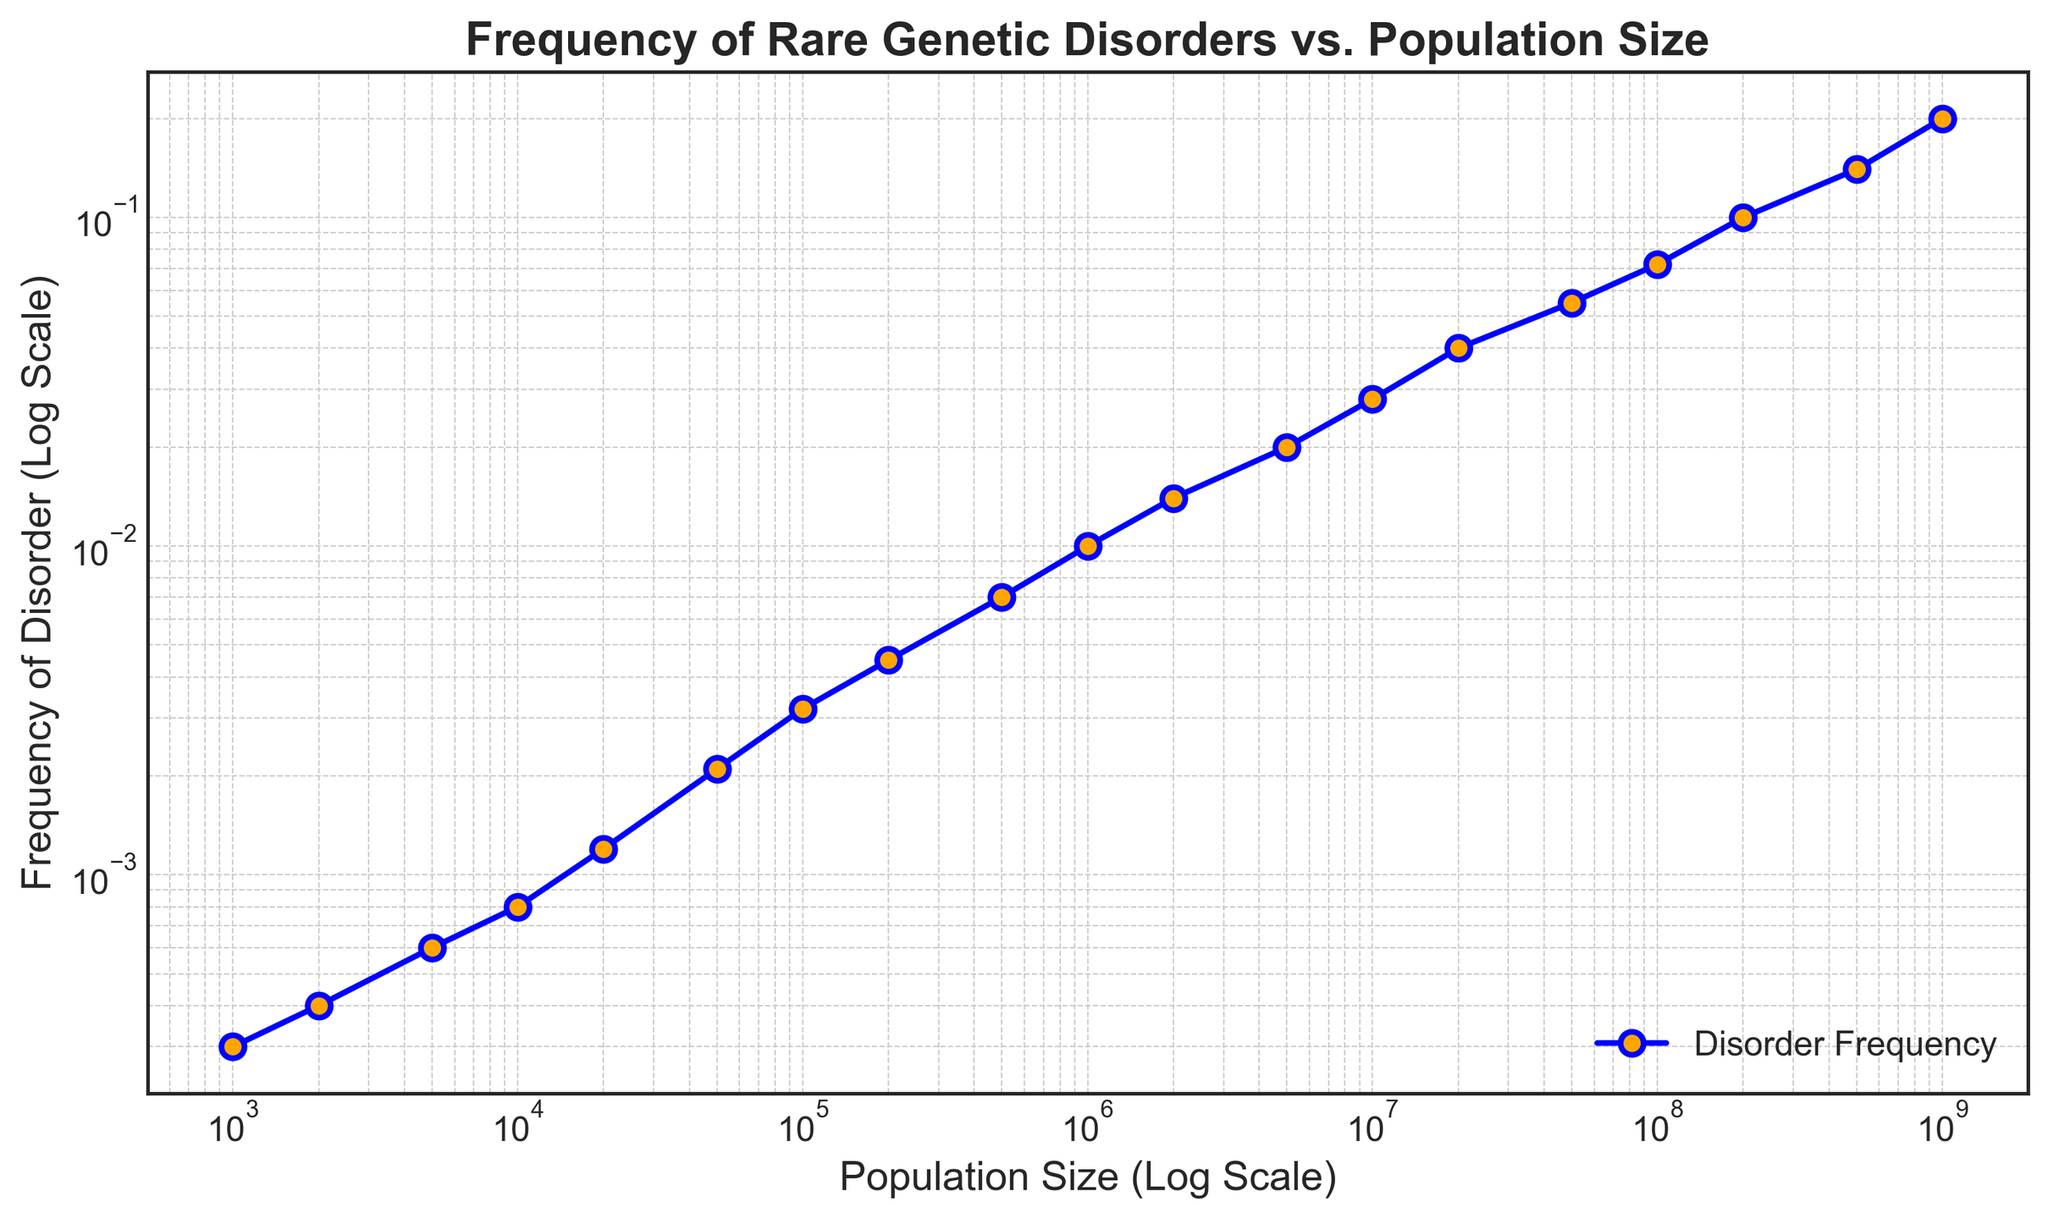What's the frequency of the disorder for a population size of 1,000,000? Locate the population size of 1,000,000 on the x-axis and find the corresponding value on the y-axis. The frequency of the disorder at that point is 0.01.
Answer: 0.01 How much more frequent is the disorder at a population size of 200,000,000 compared to 1,000,000? Locate the y-values for both population sizes. For 200,000,000, the frequency is 0.1, and for 1,000,000, it's 0.01. The difference is 0.1 - 0.01 = 0.09.
Answer: 0.09 What is the visual trend of the frequency of the disorder as the population size increases? Observe the line plot. The frequency of the disorder increases as the population size increases, displaying a generally upward trend on a log scale.
Answer: Increasing At what population size does the frequency of the disorder first exceed 0.02? Locate the y-value of 0.02 and trace it back to the x-axis. The population size corresponding to this frequency is 5,000,000.
Answer: 5,000,000 Is there a point where the increase in frequency significantly accelerates? Analyze the slope of the line. Notice the frequency increase becomes notably steeper around population sizes between 1,000,000 and 50,000,000.
Answer: Yes How many times does the frequency of the disorder increase from a population size of 10,000 to 1,000,000? Find frequencies for both sizes: 0.0008 at 10,000 and 0.01 at 1,000,000. The increase factor is 0.01 / 0.0008 = 12.5.
Answer: 12.5 Between which consecutive population sizes is the largest increase in disorder frequency observed? Compare the frequency increases between successive population size pairs. The largest increase is observed between 200,000,000 (0.1) and 500,000,000 (0.14) with an increase of 0.04.
Answer: Between 200,000,000 and 500,000,000 What's the approximate frequency of the disorder at a population size of 5,000,000? Locate the population size of 5,000,000 on the x-axis and find the corresponding y-value, which is approximately 0.02.
Answer: 0.02 By how much does the frequency of the disorder change from a population size of 100 to 10,000,000? Compare the frequencies: at 100, the data is not explicitly given but it is lower, and at 10,000,000 it's 0.028. The change is approximately 0.028 - ~0.0001 = 0.0279.
Answer: 0.0279 What can you infer about the behavior of the disorder frequency beyond the data provided (greater than 1,000,000,000)? Extrapolating from the trend shows that the frequency likely continues to increase, but exact values cannot be determined from the given data.
Answer: Increase extrapolation 